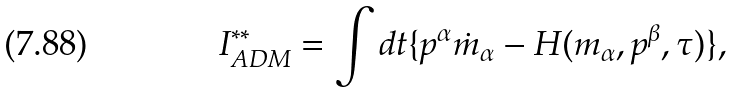<formula> <loc_0><loc_0><loc_500><loc_500>I ^ { \ast \ast } _ { A D M } = \int d t \{ p ^ { \alpha } \dot { m } _ { \alpha } - H ( m _ { \alpha } , p ^ { \beta } , \tau ) \} ,</formula> 